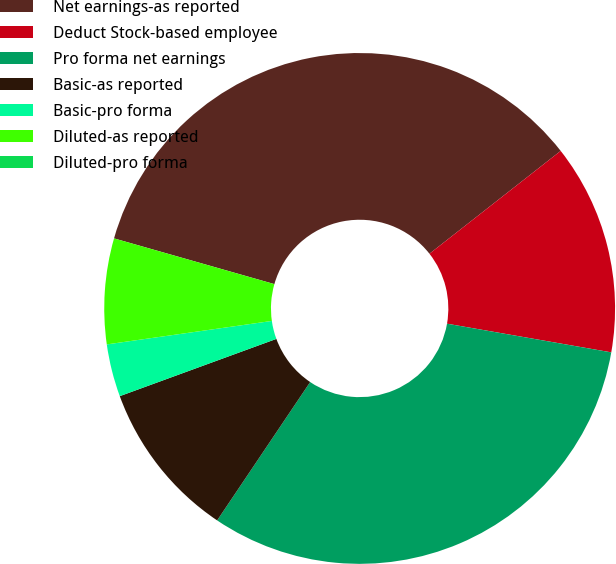<chart> <loc_0><loc_0><loc_500><loc_500><pie_chart><fcel>Net earnings-as reported<fcel>Deduct Stock-based employee<fcel>Pro forma net earnings<fcel>Basic-as reported<fcel>Basic-pro forma<fcel>Diluted-as reported<fcel>Diluted-pro forma<nl><fcel>35.0%<fcel>13.33%<fcel>31.67%<fcel>10.0%<fcel>3.33%<fcel>6.67%<fcel>0.0%<nl></chart> 